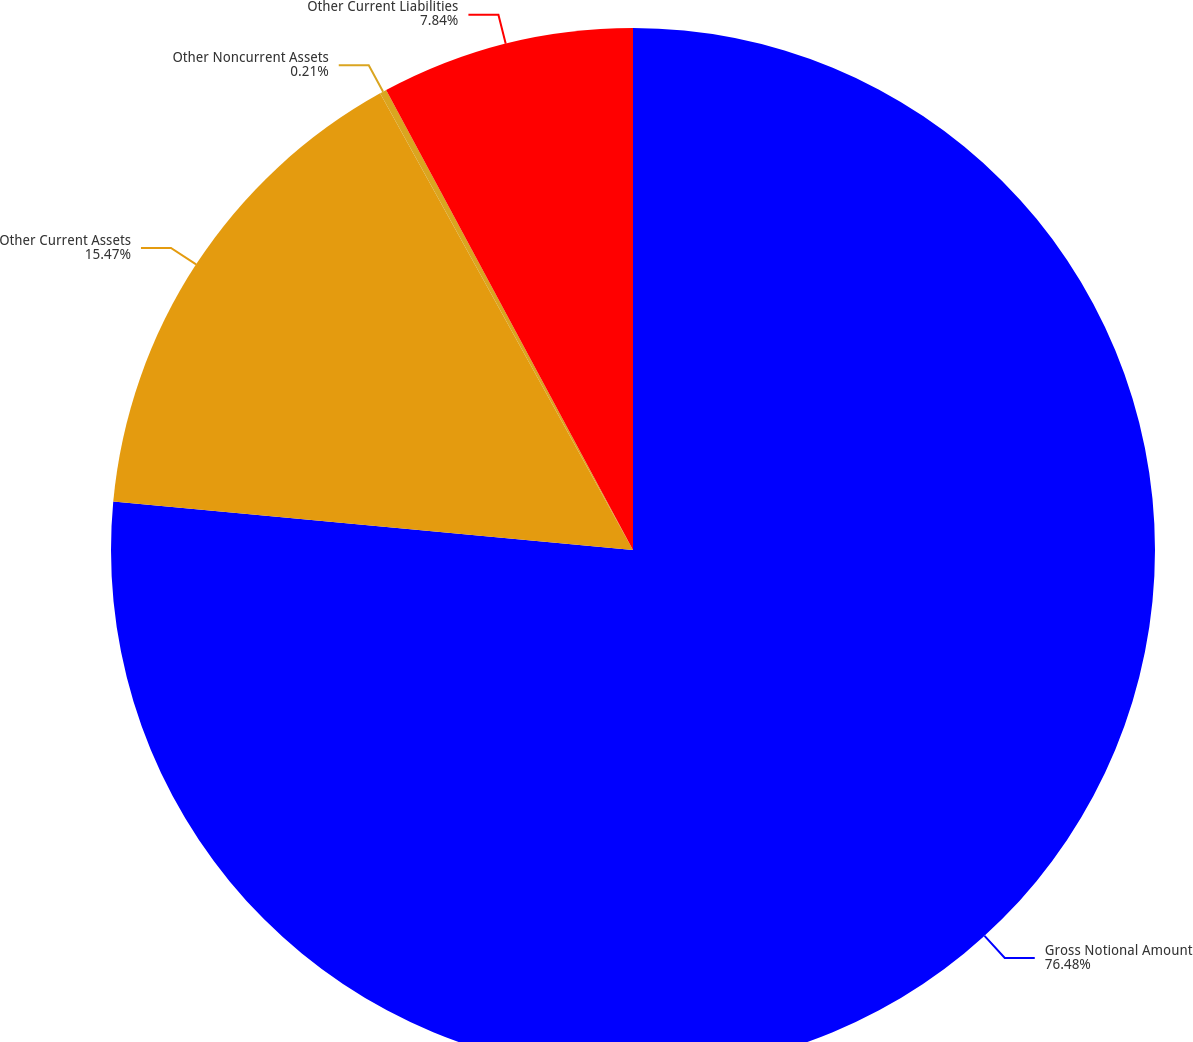<chart> <loc_0><loc_0><loc_500><loc_500><pie_chart><fcel>Gross Notional Amount<fcel>Other Current Assets<fcel>Other Noncurrent Assets<fcel>Other Current Liabilities<nl><fcel>76.48%<fcel>15.47%<fcel>0.21%<fcel>7.84%<nl></chart> 